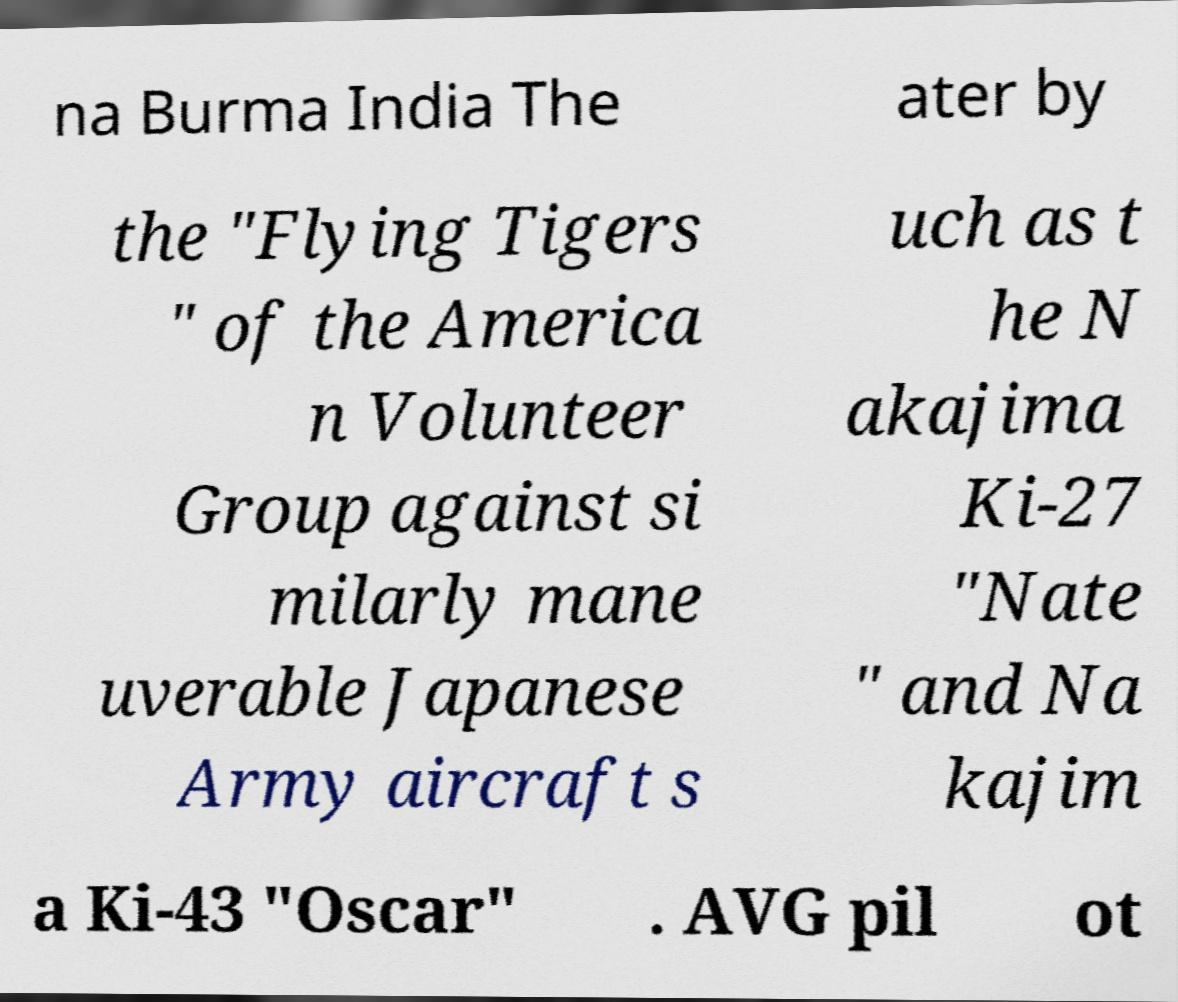What messages or text are displayed in this image? I need them in a readable, typed format. na Burma India The ater by the "Flying Tigers " of the America n Volunteer Group against si milarly mane uverable Japanese Army aircraft s uch as t he N akajima Ki-27 "Nate " and Na kajim a Ki-43 "Oscar" . AVG pil ot 